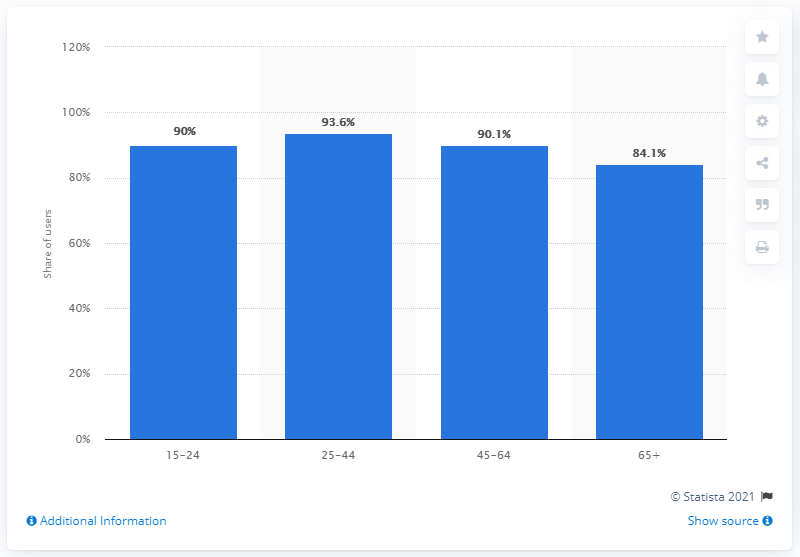Indicate a few pertinent items in this graphic. As of November 2017, 90.1% of 15-24 year old U.S. internet users accessed online mail. 